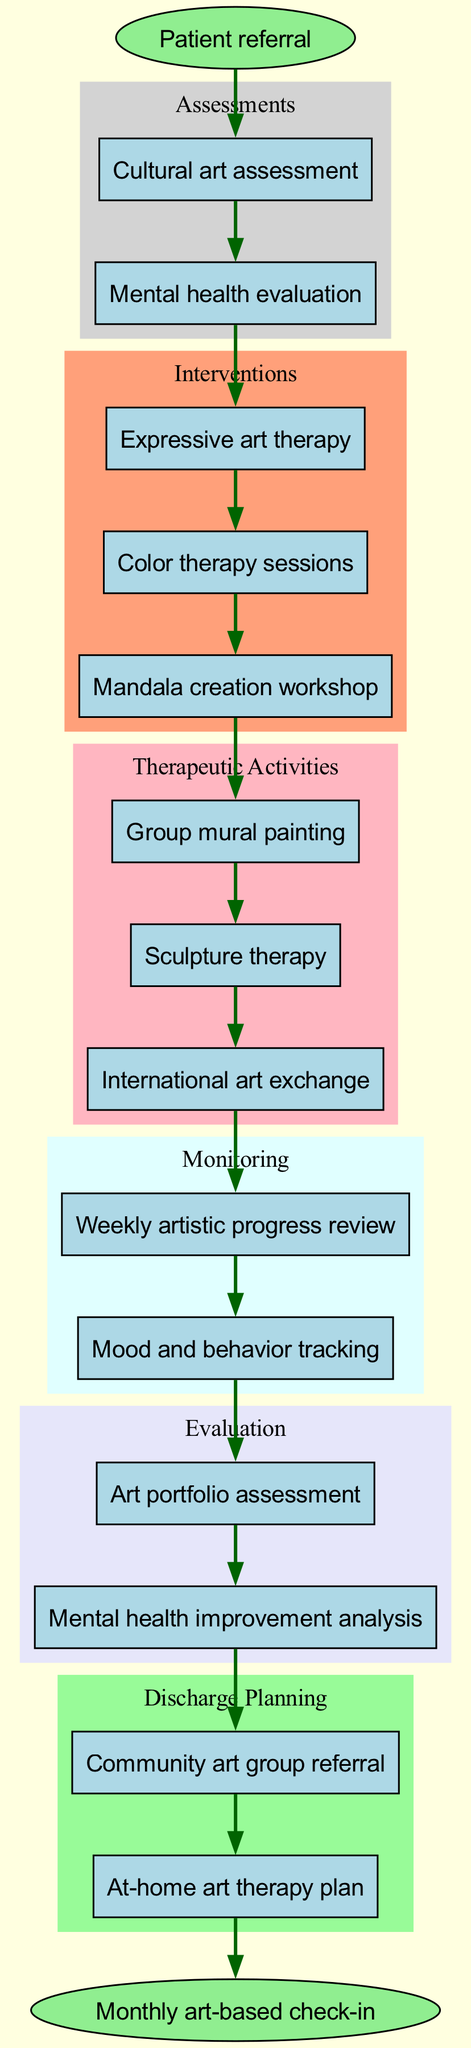What is the starting point of the clinical pathway? The starting point of the clinical pathway is defined as the "Patient referral" node. This node initiates the entire process and is depicted as the first element in the diagram.
Answer: Patient referral How many assessment nodes are there in the diagram? The diagram contains two assessment nodes: "Cultural art assessment" and "Mental health evaluation." This can be counted by looking at the cluster labeled "Assessments."
Answer: 2 What follows the "Mental health evaluation" in the pathway? After the "Mental health evaluation," the next node in the clinical pathway is "Expressive art therapy." It is directly connected as the subsequent step in the interventions cluster.
Answer: Expressive art therapy What is the last monitoring activity in the pathway? The last monitoring activity in the pathway is "Mood and behavior tracking." This can be determined by examining the "Monitoring" cluster, which shows the ordered sequence of activities in this phase.
Answer: Mood and behavior tracking How many therapeutic activities are listed in the diagram? The diagram lists three therapeutic activities: "Group mural painting," "Sculpture therapy," and "International art exchange." This can be confirmed by counting the nodes in the "Therapeutic Activities" cluster.
Answer: 3 Which assessment is performed first? The first assessment performed in the pathway is "Cultural art assessment," which is the first node in the Assessments cluster.
Answer: Cultural art assessment What types of interventions are included before therapeutic activities? The types of interventions before therapeutic activities include "Expressive art therapy," "Color therapy sessions," and "Mandala creation workshop." These interventions are listed in the "Interventions" cluster, preceding the therapeutic activities.
Answer: Expressive art therapy, Color therapy sessions, Mandala creation workshop What leads to the evaluation phase in the pathway? The monitoring phase leads to the evaluation phase, specifically after "Mood and behavior tracking" concludes, connecting to "Art portfolio assessment." This shows the transition from monitoring activities to evaluation.
Answer: Monitoring What does the follow-up stage entail? The follow-up stage entails "Monthly art-based check-in." This is the final node in the pathway and represents ongoing support after discharge.
Answer: Monthly art-based check-in 